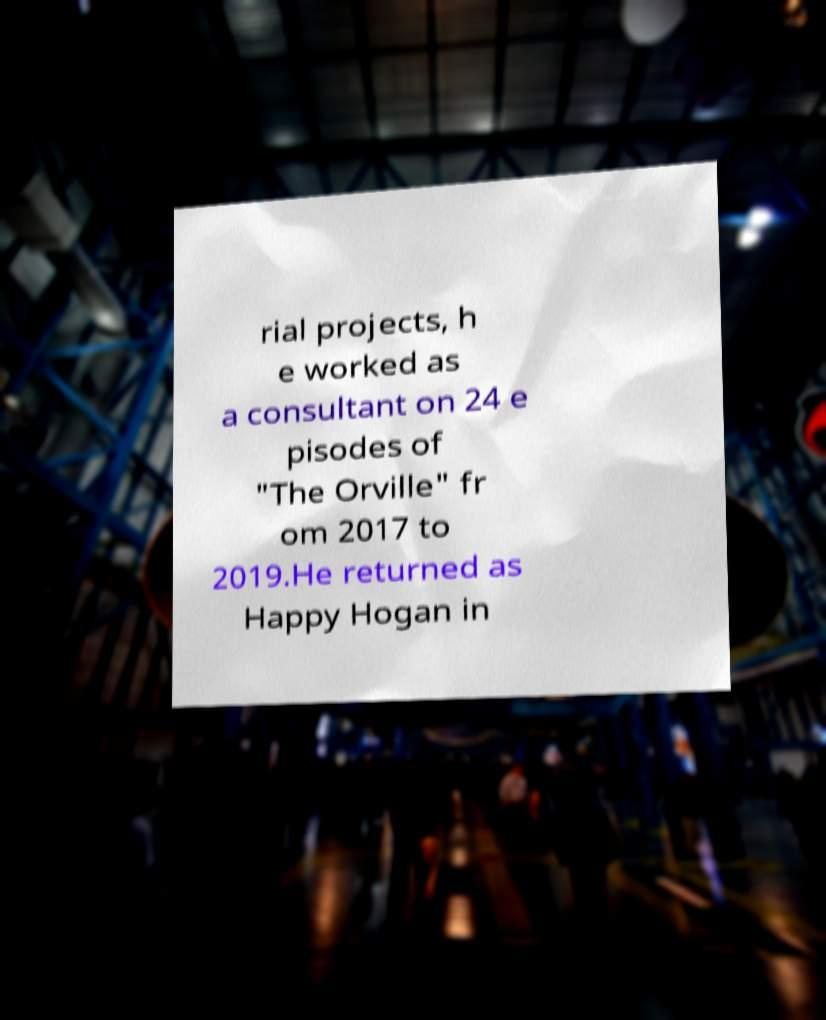Could you assist in decoding the text presented in this image and type it out clearly? rial projects, h e worked as a consultant on 24 e pisodes of "The Orville" fr om 2017 to 2019.He returned as Happy Hogan in 